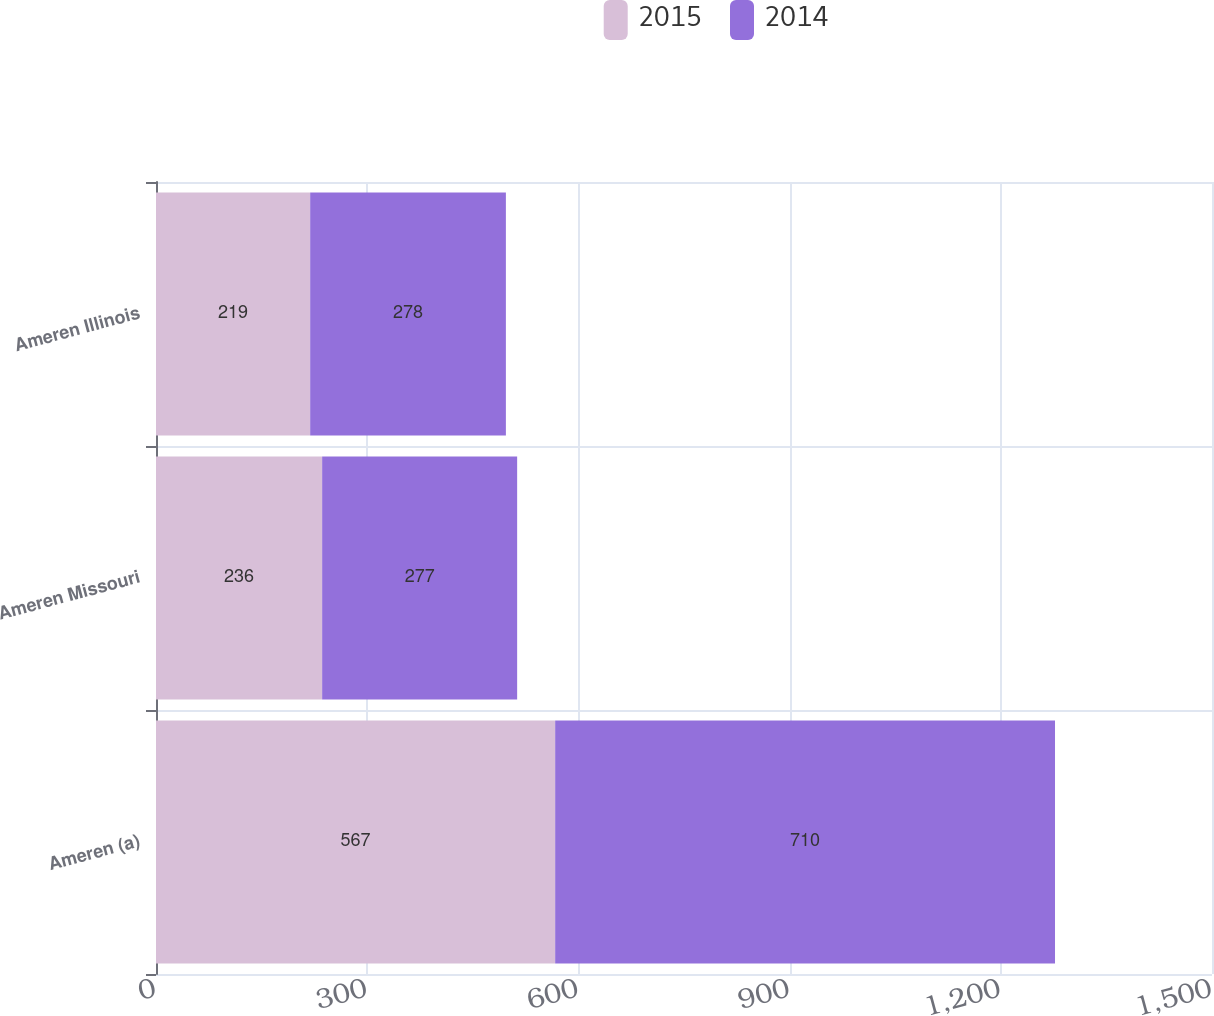Convert chart. <chart><loc_0><loc_0><loc_500><loc_500><stacked_bar_chart><ecel><fcel>Ameren (a)<fcel>Ameren Missouri<fcel>Ameren Illinois<nl><fcel>2015<fcel>567<fcel>236<fcel>219<nl><fcel>2014<fcel>710<fcel>277<fcel>278<nl></chart> 